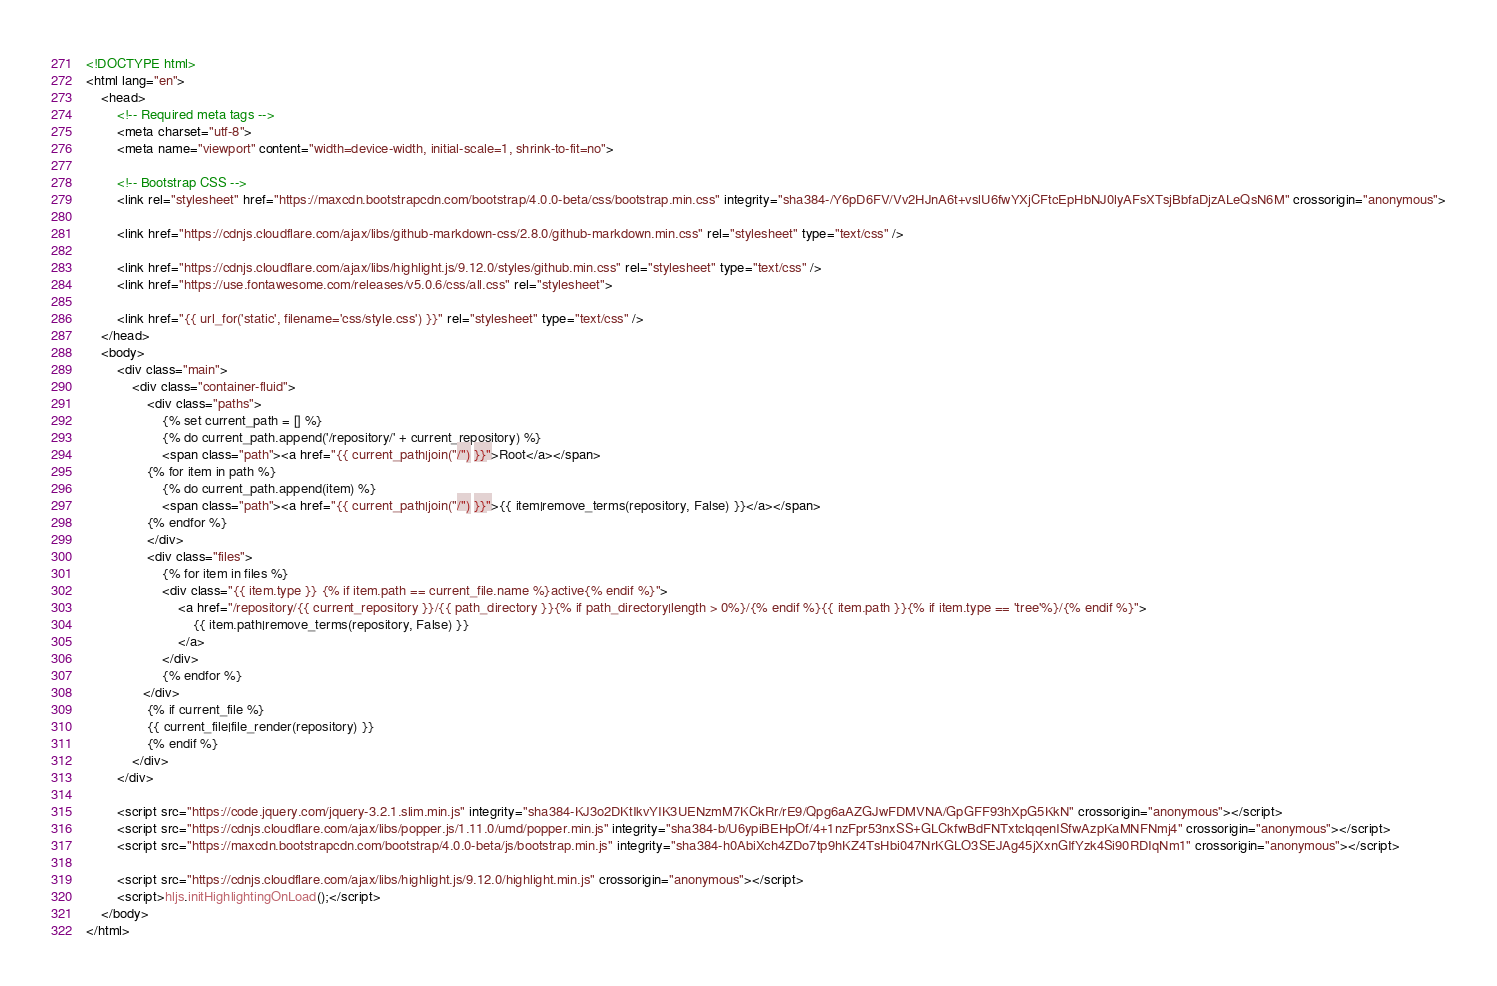<code> <loc_0><loc_0><loc_500><loc_500><_HTML_><!DOCTYPE html>
<html lang="en">
    <head>
        <!-- Required meta tags -->
        <meta charset="utf-8">
        <meta name="viewport" content="width=device-width, initial-scale=1, shrink-to-fit=no">

        <!-- Bootstrap CSS -->
        <link rel="stylesheet" href="https://maxcdn.bootstrapcdn.com/bootstrap/4.0.0-beta/css/bootstrap.min.css" integrity="sha384-/Y6pD6FV/Vv2HJnA6t+vslU6fwYXjCFtcEpHbNJ0lyAFsXTsjBbfaDjzALeQsN6M" crossorigin="anonymous">

        <link href="https://cdnjs.cloudflare.com/ajax/libs/github-markdown-css/2.8.0/github-markdown.min.css" rel="stylesheet" type="text/css" />

        <link href="https://cdnjs.cloudflare.com/ajax/libs/highlight.js/9.12.0/styles/github.min.css" rel="stylesheet" type="text/css" />
        <link href="https://use.fontawesome.com/releases/v5.0.6/css/all.css" rel="stylesheet">

        <link href="{{ url_for('static', filename='css/style.css') }}" rel="stylesheet" type="text/css" />
    </head>
    <body>
        <div class="main">
            <div class="container-fluid">
                <div class="paths">
                    {% set current_path = [] %}
                    {% do current_path.append('/repository/' + current_repository) %}
                    <span class="path"><a href="{{ current_path|join("/") }}">Root</a></span>
                {% for item in path %}
                    {% do current_path.append(item) %}
                    <span class="path"><a href="{{ current_path|join("/") }}">{{ item|remove_terms(repository, False) }}</a></span>
                {% endfor %}
                </div>
                <div class="files">
                    {% for item in files %}
                    <div class="{{ item.type }} {% if item.path == current_file.name %}active{% endif %}">
                        <a href="/repository/{{ current_repository }}/{{ path_directory }}{% if path_directory|length > 0%}/{% endif %}{{ item.path }}{% if item.type == 'tree'%}/{% endif %}">
                            {{ item.path|remove_terms(repository, False) }}
                        </a>
                    </div>
                    {% endfor %}
               </div>
                {% if current_file %}
                {{ current_file|file_render(repository) }}
                {% endif %}
            </div>
        </div>

        <script src="https://code.jquery.com/jquery-3.2.1.slim.min.js" integrity="sha384-KJ3o2DKtIkvYIK3UENzmM7KCkRr/rE9/Qpg6aAZGJwFDMVNA/GpGFF93hXpG5KkN" crossorigin="anonymous"></script>
        <script src="https://cdnjs.cloudflare.com/ajax/libs/popper.js/1.11.0/umd/popper.min.js" integrity="sha384-b/U6ypiBEHpOf/4+1nzFpr53nxSS+GLCkfwBdFNTxtclqqenISfwAzpKaMNFNmj4" crossorigin="anonymous"></script>
        <script src="https://maxcdn.bootstrapcdn.com/bootstrap/4.0.0-beta/js/bootstrap.min.js" integrity="sha384-h0AbiXch4ZDo7tp9hKZ4TsHbi047NrKGLO3SEJAg45jXxnGIfYzk4Si90RDIqNm1" crossorigin="anonymous"></script>

        <script src="https://cdnjs.cloudflare.com/ajax/libs/highlight.js/9.12.0/highlight.min.js" crossorigin="anonymous"></script>
        <script>hljs.initHighlightingOnLoad();</script>
    </body>
</html></code> 